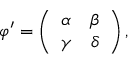<formula> <loc_0><loc_0><loc_500><loc_500>\varphi ^ { \prime } = \left ( \begin{array} { c c } { \alpha } & { \beta } \\ { \gamma } & { \delta } \end{array} \right ) ,</formula> 